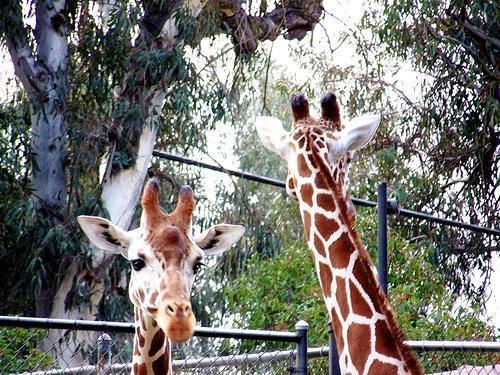How many animals are in the picture?
Give a very brief answer. 2. How many giraffes are in the photo?
Give a very brief answer. 2. How many eyes are visible?
Give a very brief answer. 2. How many ears are shown?
Give a very brief answer. 4. 